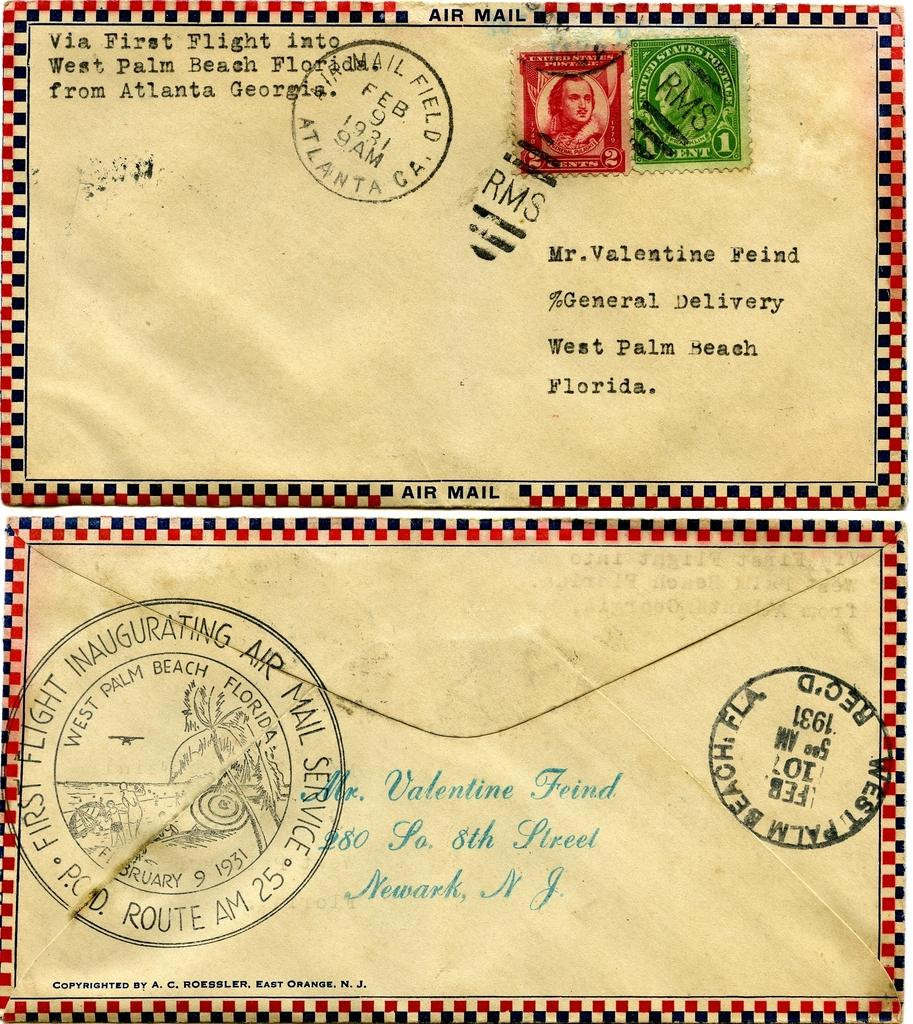<image>
Describe the image concisely. envelope thats been stamped  from the year 1931 